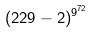<formula> <loc_0><loc_0><loc_500><loc_500>( 2 2 9 - 2 ) ^ { 9 ^ { 7 2 } }</formula> 